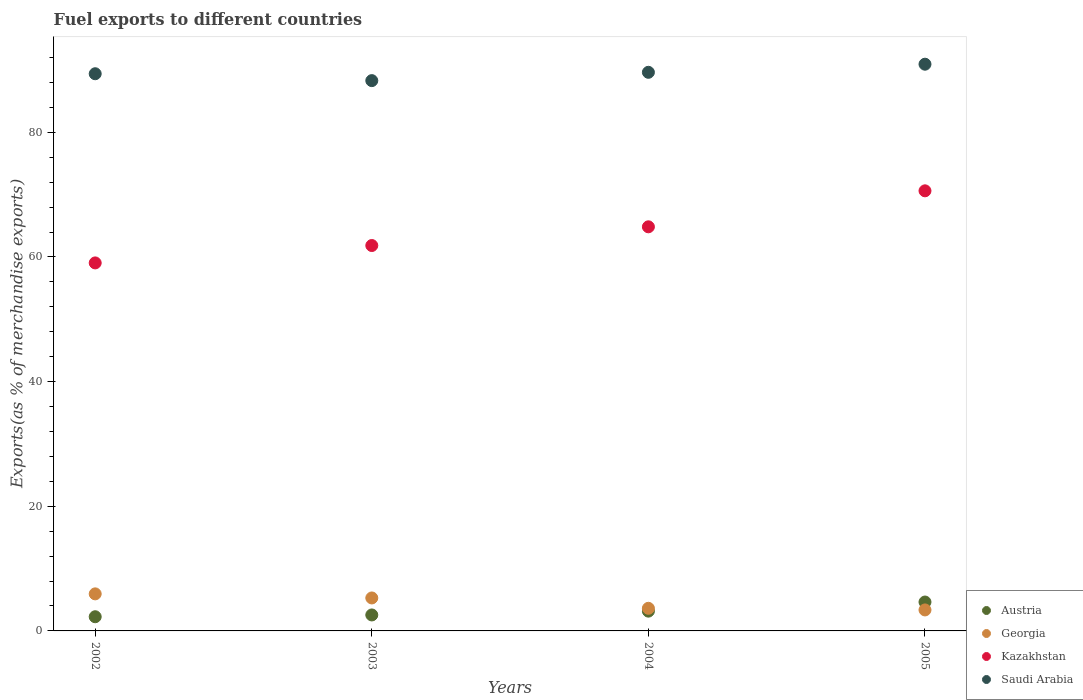What is the percentage of exports to different countries in Georgia in 2004?
Your response must be concise. 3.63. Across all years, what is the maximum percentage of exports to different countries in Georgia?
Give a very brief answer. 5.95. Across all years, what is the minimum percentage of exports to different countries in Saudi Arabia?
Keep it short and to the point. 88.3. In which year was the percentage of exports to different countries in Saudi Arabia maximum?
Your answer should be compact. 2005. What is the total percentage of exports to different countries in Austria in the graph?
Offer a terse response. 12.65. What is the difference between the percentage of exports to different countries in Kazakhstan in 2003 and that in 2005?
Offer a very short reply. -8.78. What is the difference between the percentage of exports to different countries in Saudi Arabia in 2004 and the percentage of exports to different countries in Georgia in 2002?
Ensure brevity in your answer.  83.69. What is the average percentage of exports to different countries in Kazakhstan per year?
Your response must be concise. 64.09. In the year 2002, what is the difference between the percentage of exports to different countries in Georgia and percentage of exports to different countries in Kazakhstan?
Keep it short and to the point. -53.1. What is the ratio of the percentage of exports to different countries in Kazakhstan in 2002 to that in 2003?
Provide a short and direct response. 0.95. Is the difference between the percentage of exports to different countries in Georgia in 2002 and 2003 greater than the difference between the percentage of exports to different countries in Kazakhstan in 2002 and 2003?
Keep it short and to the point. Yes. What is the difference between the highest and the second highest percentage of exports to different countries in Georgia?
Your answer should be compact. 0.66. What is the difference between the highest and the lowest percentage of exports to different countries in Saudi Arabia?
Your answer should be very brief. 2.64. In how many years, is the percentage of exports to different countries in Georgia greater than the average percentage of exports to different countries in Georgia taken over all years?
Give a very brief answer. 2. Is it the case that in every year, the sum of the percentage of exports to different countries in Austria and percentage of exports to different countries in Kazakhstan  is greater than the percentage of exports to different countries in Saudi Arabia?
Keep it short and to the point. No. Is the percentage of exports to different countries in Kazakhstan strictly greater than the percentage of exports to different countries in Georgia over the years?
Offer a very short reply. Yes. Is the percentage of exports to different countries in Georgia strictly less than the percentage of exports to different countries in Austria over the years?
Provide a short and direct response. No. How many dotlines are there?
Make the answer very short. 4. What is the difference between two consecutive major ticks on the Y-axis?
Your answer should be compact. 20. Are the values on the major ticks of Y-axis written in scientific E-notation?
Make the answer very short. No. Does the graph contain any zero values?
Keep it short and to the point. No. Where does the legend appear in the graph?
Your response must be concise. Bottom right. How many legend labels are there?
Make the answer very short. 4. What is the title of the graph?
Make the answer very short. Fuel exports to different countries. What is the label or title of the X-axis?
Your response must be concise. Years. What is the label or title of the Y-axis?
Give a very brief answer. Exports(as % of merchandise exports). What is the Exports(as % of merchandise exports) in Austria in 2002?
Provide a short and direct response. 2.28. What is the Exports(as % of merchandise exports) of Georgia in 2002?
Your response must be concise. 5.95. What is the Exports(as % of merchandise exports) in Kazakhstan in 2002?
Offer a terse response. 59.05. What is the Exports(as % of merchandise exports) of Saudi Arabia in 2002?
Give a very brief answer. 89.4. What is the Exports(as % of merchandise exports) in Austria in 2003?
Give a very brief answer. 2.56. What is the Exports(as % of merchandise exports) in Georgia in 2003?
Offer a terse response. 5.29. What is the Exports(as % of merchandise exports) in Kazakhstan in 2003?
Give a very brief answer. 61.84. What is the Exports(as % of merchandise exports) of Saudi Arabia in 2003?
Provide a short and direct response. 88.3. What is the Exports(as % of merchandise exports) in Austria in 2004?
Make the answer very short. 3.17. What is the Exports(as % of merchandise exports) in Georgia in 2004?
Make the answer very short. 3.63. What is the Exports(as % of merchandise exports) of Kazakhstan in 2004?
Your answer should be very brief. 64.84. What is the Exports(as % of merchandise exports) of Saudi Arabia in 2004?
Your answer should be compact. 89.63. What is the Exports(as % of merchandise exports) of Austria in 2005?
Your answer should be very brief. 4.64. What is the Exports(as % of merchandise exports) of Georgia in 2005?
Your answer should be very brief. 3.37. What is the Exports(as % of merchandise exports) in Kazakhstan in 2005?
Provide a succinct answer. 70.62. What is the Exports(as % of merchandise exports) in Saudi Arabia in 2005?
Keep it short and to the point. 90.94. Across all years, what is the maximum Exports(as % of merchandise exports) of Austria?
Your answer should be compact. 4.64. Across all years, what is the maximum Exports(as % of merchandise exports) in Georgia?
Offer a very short reply. 5.95. Across all years, what is the maximum Exports(as % of merchandise exports) in Kazakhstan?
Give a very brief answer. 70.62. Across all years, what is the maximum Exports(as % of merchandise exports) in Saudi Arabia?
Make the answer very short. 90.94. Across all years, what is the minimum Exports(as % of merchandise exports) of Austria?
Give a very brief answer. 2.28. Across all years, what is the minimum Exports(as % of merchandise exports) in Georgia?
Your answer should be compact. 3.37. Across all years, what is the minimum Exports(as % of merchandise exports) of Kazakhstan?
Offer a very short reply. 59.05. Across all years, what is the minimum Exports(as % of merchandise exports) in Saudi Arabia?
Make the answer very short. 88.3. What is the total Exports(as % of merchandise exports) in Austria in the graph?
Give a very brief answer. 12.65. What is the total Exports(as % of merchandise exports) of Georgia in the graph?
Ensure brevity in your answer.  18.23. What is the total Exports(as % of merchandise exports) of Kazakhstan in the graph?
Your answer should be very brief. 256.35. What is the total Exports(as % of merchandise exports) of Saudi Arabia in the graph?
Your answer should be very brief. 358.28. What is the difference between the Exports(as % of merchandise exports) of Austria in 2002 and that in 2003?
Offer a terse response. -0.29. What is the difference between the Exports(as % of merchandise exports) in Georgia in 2002 and that in 2003?
Keep it short and to the point. 0.66. What is the difference between the Exports(as % of merchandise exports) of Kazakhstan in 2002 and that in 2003?
Ensure brevity in your answer.  -2.79. What is the difference between the Exports(as % of merchandise exports) of Saudi Arabia in 2002 and that in 2003?
Give a very brief answer. 1.1. What is the difference between the Exports(as % of merchandise exports) in Austria in 2002 and that in 2004?
Make the answer very short. -0.9. What is the difference between the Exports(as % of merchandise exports) of Georgia in 2002 and that in 2004?
Your response must be concise. 2.31. What is the difference between the Exports(as % of merchandise exports) of Kazakhstan in 2002 and that in 2004?
Offer a terse response. -5.79. What is the difference between the Exports(as % of merchandise exports) of Saudi Arabia in 2002 and that in 2004?
Make the answer very short. -0.23. What is the difference between the Exports(as % of merchandise exports) of Austria in 2002 and that in 2005?
Give a very brief answer. -2.36. What is the difference between the Exports(as % of merchandise exports) of Georgia in 2002 and that in 2005?
Give a very brief answer. 2.58. What is the difference between the Exports(as % of merchandise exports) of Kazakhstan in 2002 and that in 2005?
Your response must be concise. -11.57. What is the difference between the Exports(as % of merchandise exports) in Saudi Arabia in 2002 and that in 2005?
Offer a terse response. -1.53. What is the difference between the Exports(as % of merchandise exports) in Austria in 2003 and that in 2004?
Your response must be concise. -0.61. What is the difference between the Exports(as % of merchandise exports) of Georgia in 2003 and that in 2004?
Provide a succinct answer. 1.66. What is the difference between the Exports(as % of merchandise exports) of Kazakhstan in 2003 and that in 2004?
Make the answer very short. -3. What is the difference between the Exports(as % of merchandise exports) of Saudi Arabia in 2003 and that in 2004?
Give a very brief answer. -1.33. What is the difference between the Exports(as % of merchandise exports) of Austria in 2003 and that in 2005?
Give a very brief answer. -2.07. What is the difference between the Exports(as % of merchandise exports) of Georgia in 2003 and that in 2005?
Provide a short and direct response. 1.92. What is the difference between the Exports(as % of merchandise exports) of Kazakhstan in 2003 and that in 2005?
Offer a terse response. -8.78. What is the difference between the Exports(as % of merchandise exports) in Saudi Arabia in 2003 and that in 2005?
Your answer should be very brief. -2.64. What is the difference between the Exports(as % of merchandise exports) in Austria in 2004 and that in 2005?
Offer a very short reply. -1.46. What is the difference between the Exports(as % of merchandise exports) in Georgia in 2004 and that in 2005?
Give a very brief answer. 0.26. What is the difference between the Exports(as % of merchandise exports) of Kazakhstan in 2004 and that in 2005?
Ensure brevity in your answer.  -5.77. What is the difference between the Exports(as % of merchandise exports) of Saudi Arabia in 2004 and that in 2005?
Your answer should be very brief. -1.3. What is the difference between the Exports(as % of merchandise exports) in Austria in 2002 and the Exports(as % of merchandise exports) in Georgia in 2003?
Your answer should be compact. -3.01. What is the difference between the Exports(as % of merchandise exports) of Austria in 2002 and the Exports(as % of merchandise exports) of Kazakhstan in 2003?
Offer a terse response. -59.57. What is the difference between the Exports(as % of merchandise exports) in Austria in 2002 and the Exports(as % of merchandise exports) in Saudi Arabia in 2003?
Keep it short and to the point. -86.02. What is the difference between the Exports(as % of merchandise exports) in Georgia in 2002 and the Exports(as % of merchandise exports) in Kazakhstan in 2003?
Keep it short and to the point. -55.9. What is the difference between the Exports(as % of merchandise exports) in Georgia in 2002 and the Exports(as % of merchandise exports) in Saudi Arabia in 2003?
Ensure brevity in your answer.  -82.35. What is the difference between the Exports(as % of merchandise exports) of Kazakhstan in 2002 and the Exports(as % of merchandise exports) of Saudi Arabia in 2003?
Give a very brief answer. -29.25. What is the difference between the Exports(as % of merchandise exports) in Austria in 2002 and the Exports(as % of merchandise exports) in Georgia in 2004?
Make the answer very short. -1.35. What is the difference between the Exports(as % of merchandise exports) of Austria in 2002 and the Exports(as % of merchandise exports) of Kazakhstan in 2004?
Your answer should be very brief. -62.57. What is the difference between the Exports(as % of merchandise exports) of Austria in 2002 and the Exports(as % of merchandise exports) of Saudi Arabia in 2004?
Your answer should be very brief. -87.36. What is the difference between the Exports(as % of merchandise exports) of Georgia in 2002 and the Exports(as % of merchandise exports) of Kazakhstan in 2004?
Give a very brief answer. -58.9. What is the difference between the Exports(as % of merchandise exports) of Georgia in 2002 and the Exports(as % of merchandise exports) of Saudi Arabia in 2004?
Provide a succinct answer. -83.69. What is the difference between the Exports(as % of merchandise exports) in Kazakhstan in 2002 and the Exports(as % of merchandise exports) in Saudi Arabia in 2004?
Make the answer very short. -30.58. What is the difference between the Exports(as % of merchandise exports) in Austria in 2002 and the Exports(as % of merchandise exports) in Georgia in 2005?
Make the answer very short. -1.09. What is the difference between the Exports(as % of merchandise exports) in Austria in 2002 and the Exports(as % of merchandise exports) in Kazakhstan in 2005?
Ensure brevity in your answer.  -68.34. What is the difference between the Exports(as % of merchandise exports) of Austria in 2002 and the Exports(as % of merchandise exports) of Saudi Arabia in 2005?
Your answer should be very brief. -88.66. What is the difference between the Exports(as % of merchandise exports) of Georgia in 2002 and the Exports(as % of merchandise exports) of Kazakhstan in 2005?
Provide a short and direct response. -64.67. What is the difference between the Exports(as % of merchandise exports) of Georgia in 2002 and the Exports(as % of merchandise exports) of Saudi Arabia in 2005?
Ensure brevity in your answer.  -84.99. What is the difference between the Exports(as % of merchandise exports) in Kazakhstan in 2002 and the Exports(as % of merchandise exports) in Saudi Arabia in 2005?
Keep it short and to the point. -31.89. What is the difference between the Exports(as % of merchandise exports) in Austria in 2003 and the Exports(as % of merchandise exports) in Georgia in 2004?
Make the answer very short. -1.07. What is the difference between the Exports(as % of merchandise exports) in Austria in 2003 and the Exports(as % of merchandise exports) in Kazakhstan in 2004?
Make the answer very short. -62.28. What is the difference between the Exports(as % of merchandise exports) in Austria in 2003 and the Exports(as % of merchandise exports) in Saudi Arabia in 2004?
Make the answer very short. -87.07. What is the difference between the Exports(as % of merchandise exports) in Georgia in 2003 and the Exports(as % of merchandise exports) in Kazakhstan in 2004?
Ensure brevity in your answer.  -59.55. What is the difference between the Exports(as % of merchandise exports) of Georgia in 2003 and the Exports(as % of merchandise exports) of Saudi Arabia in 2004?
Your answer should be very brief. -84.34. What is the difference between the Exports(as % of merchandise exports) in Kazakhstan in 2003 and the Exports(as % of merchandise exports) in Saudi Arabia in 2004?
Your response must be concise. -27.79. What is the difference between the Exports(as % of merchandise exports) in Austria in 2003 and the Exports(as % of merchandise exports) in Georgia in 2005?
Your answer should be compact. -0.81. What is the difference between the Exports(as % of merchandise exports) in Austria in 2003 and the Exports(as % of merchandise exports) in Kazakhstan in 2005?
Give a very brief answer. -68.06. What is the difference between the Exports(as % of merchandise exports) in Austria in 2003 and the Exports(as % of merchandise exports) in Saudi Arabia in 2005?
Offer a terse response. -88.37. What is the difference between the Exports(as % of merchandise exports) of Georgia in 2003 and the Exports(as % of merchandise exports) of Kazakhstan in 2005?
Give a very brief answer. -65.33. What is the difference between the Exports(as % of merchandise exports) of Georgia in 2003 and the Exports(as % of merchandise exports) of Saudi Arabia in 2005?
Your answer should be compact. -85.65. What is the difference between the Exports(as % of merchandise exports) in Kazakhstan in 2003 and the Exports(as % of merchandise exports) in Saudi Arabia in 2005?
Your answer should be very brief. -29.09. What is the difference between the Exports(as % of merchandise exports) of Austria in 2004 and the Exports(as % of merchandise exports) of Georgia in 2005?
Your response must be concise. -0.19. What is the difference between the Exports(as % of merchandise exports) of Austria in 2004 and the Exports(as % of merchandise exports) of Kazakhstan in 2005?
Keep it short and to the point. -67.44. What is the difference between the Exports(as % of merchandise exports) in Austria in 2004 and the Exports(as % of merchandise exports) in Saudi Arabia in 2005?
Offer a very short reply. -87.76. What is the difference between the Exports(as % of merchandise exports) in Georgia in 2004 and the Exports(as % of merchandise exports) in Kazakhstan in 2005?
Provide a short and direct response. -66.99. What is the difference between the Exports(as % of merchandise exports) in Georgia in 2004 and the Exports(as % of merchandise exports) in Saudi Arabia in 2005?
Your response must be concise. -87.31. What is the difference between the Exports(as % of merchandise exports) of Kazakhstan in 2004 and the Exports(as % of merchandise exports) of Saudi Arabia in 2005?
Make the answer very short. -26.09. What is the average Exports(as % of merchandise exports) of Austria per year?
Your answer should be compact. 3.16. What is the average Exports(as % of merchandise exports) of Georgia per year?
Provide a succinct answer. 4.56. What is the average Exports(as % of merchandise exports) in Kazakhstan per year?
Offer a very short reply. 64.09. What is the average Exports(as % of merchandise exports) in Saudi Arabia per year?
Your response must be concise. 89.57. In the year 2002, what is the difference between the Exports(as % of merchandise exports) in Austria and Exports(as % of merchandise exports) in Georgia?
Give a very brief answer. -3.67. In the year 2002, what is the difference between the Exports(as % of merchandise exports) of Austria and Exports(as % of merchandise exports) of Kazakhstan?
Your answer should be very brief. -56.77. In the year 2002, what is the difference between the Exports(as % of merchandise exports) of Austria and Exports(as % of merchandise exports) of Saudi Arabia?
Keep it short and to the point. -87.13. In the year 2002, what is the difference between the Exports(as % of merchandise exports) of Georgia and Exports(as % of merchandise exports) of Kazakhstan?
Your response must be concise. -53.1. In the year 2002, what is the difference between the Exports(as % of merchandise exports) of Georgia and Exports(as % of merchandise exports) of Saudi Arabia?
Keep it short and to the point. -83.46. In the year 2002, what is the difference between the Exports(as % of merchandise exports) in Kazakhstan and Exports(as % of merchandise exports) in Saudi Arabia?
Ensure brevity in your answer.  -30.35. In the year 2003, what is the difference between the Exports(as % of merchandise exports) in Austria and Exports(as % of merchandise exports) in Georgia?
Provide a succinct answer. -2.73. In the year 2003, what is the difference between the Exports(as % of merchandise exports) in Austria and Exports(as % of merchandise exports) in Kazakhstan?
Provide a succinct answer. -59.28. In the year 2003, what is the difference between the Exports(as % of merchandise exports) of Austria and Exports(as % of merchandise exports) of Saudi Arabia?
Offer a very short reply. -85.74. In the year 2003, what is the difference between the Exports(as % of merchandise exports) of Georgia and Exports(as % of merchandise exports) of Kazakhstan?
Make the answer very short. -56.55. In the year 2003, what is the difference between the Exports(as % of merchandise exports) of Georgia and Exports(as % of merchandise exports) of Saudi Arabia?
Provide a short and direct response. -83.01. In the year 2003, what is the difference between the Exports(as % of merchandise exports) of Kazakhstan and Exports(as % of merchandise exports) of Saudi Arabia?
Offer a very short reply. -26.46. In the year 2004, what is the difference between the Exports(as % of merchandise exports) in Austria and Exports(as % of merchandise exports) in Georgia?
Offer a very short reply. -0.46. In the year 2004, what is the difference between the Exports(as % of merchandise exports) of Austria and Exports(as % of merchandise exports) of Kazakhstan?
Keep it short and to the point. -61.67. In the year 2004, what is the difference between the Exports(as % of merchandise exports) in Austria and Exports(as % of merchandise exports) in Saudi Arabia?
Provide a succinct answer. -86.46. In the year 2004, what is the difference between the Exports(as % of merchandise exports) in Georgia and Exports(as % of merchandise exports) in Kazakhstan?
Keep it short and to the point. -61.21. In the year 2004, what is the difference between the Exports(as % of merchandise exports) of Georgia and Exports(as % of merchandise exports) of Saudi Arabia?
Your response must be concise. -86. In the year 2004, what is the difference between the Exports(as % of merchandise exports) of Kazakhstan and Exports(as % of merchandise exports) of Saudi Arabia?
Keep it short and to the point. -24.79. In the year 2005, what is the difference between the Exports(as % of merchandise exports) of Austria and Exports(as % of merchandise exports) of Georgia?
Keep it short and to the point. 1.27. In the year 2005, what is the difference between the Exports(as % of merchandise exports) in Austria and Exports(as % of merchandise exports) in Kazakhstan?
Give a very brief answer. -65.98. In the year 2005, what is the difference between the Exports(as % of merchandise exports) in Austria and Exports(as % of merchandise exports) in Saudi Arabia?
Provide a short and direct response. -86.3. In the year 2005, what is the difference between the Exports(as % of merchandise exports) in Georgia and Exports(as % of merchandise exports) in Kazakhstan?
Your response must be concise. -67.25. In the year 2005, what is the difference between the Exports(as % of merchandise exports) of Georgia and Exports(as % of merchandise exports) of Saudi Arabia?
Offer a terse response. -87.57. In the year 2005, what is the difference between the Exports(as % of merchandise exports) of Kazakhstan and Exports(as % of merchandise exports) of Saudi Arabia?
Your answer should be very brief. -20.32. What is the ratio of the Exports(as % of merchandise exports) in Austria in 2002 to that in 2003?
Offer a very short reply. 0.89. What is the ratio of the Exports(as % of merchandise exports) in Georgia in 2002 to that in 2003?
Offer a terse response. 1.12. What is the ratio of the Exports(as % of merchandise exports) in Kazakhstan in 2002 to that in 2003?
Keep it short and to the point. 0.95. What is the ratio of the Exports(as % of merchandise exports) in Saudi Arabia in 2002 to that in 2003?
Your response must be concise. 1.01. What is the ratio of the Exports(as % of merchandise exports) of Austria in 2002 to that in 2004?
Provide a succinct answer. 0.72. What is the ratio of the Exports(as % of merchandise exports) in Georgia in 2002 to that in 2004?
Offer a very short reply. 1.64. What is the ratio of the Exports(as % of merchandise exports) of Kazakhstan in 2002 to that in 2004?
Offer a terse response. 0.91. What is the ratio of the Exports(as % of merchandise exports) of Saudi Arabia in 2002 to that in 2004?
Give a very brief answer. 1. What is the ratio of the Exports(as % of merchandise exports) of Austria in 2002 to that in 2005?
Offer a terse response. 0.49. What is the ratio of the Exports(as % of merchandise exports) in Georgia in 2002 to that in 2005?
Your answer should be compact. 1.77. What is the ratio of the Exports(as % of merchandise exports) in Kazakhstan in 2002 to that in 2005?
Your answer should be very brief. 0.84. What is the ratio of the Exports(as % of merchandise exports) of Saudi Arabia in 2002 to that in 2005?
Ensure brevity in your answer.  0.98. What is the ratio of the Exports(as % of merchandise exports) in Austria in 2003 to that in 2004?
Give a very brief answer. 0.81. What is the ratio of the Exports(as % of merchandise exports) of Georgia in 2003 to that in 2004?
Offer a very short reply. 1.46. What is the ratio of the Exports(as % of merchandise exports) of Kazakhstan in 2003 to that in 2004?
Provide a short and direct response. 0.95. What is the ratio of the Exports(as % of merchandise exports) of Saudi Arabia in 2003 to that in 2004?
Ensure brevity in your answer.  0.99. What is the ratio of the Exports(as % of merchandise exports) in Austria in 2003 to that in 2005?
Provide a succinct answer. 0.55. What is the ratio of the Exports(as % of merchandise exports) of Georgia in 2003 to that in 2005?
Ensure brevity in your answer.  1.57. What is the ratio of the Exports(as % of merchandise exports) in Kazakhstan in 2003 to that in 2005?
Provide a short and direct response. 0.88. What is the ratio of the Exports(as % of merchandise exports) in Saudi Arabia in 2003 to that in 2005?
Make the answer very short. 0.97. What is the ratio of the Exports(as % of merchandise exports) in Austria in 2004 to that in 2005?
Your response must be concise. 0.68. What is the ratio of the Exports(as % of merchandise exports) in Georgia in 2004 to that in 2005?
Give a very brief answer. 1.08. What is the ratio of the Exports(as % of merchandise exports) in Kazakhstan in 2004 to that in 2005?
Your response must be concise. 0.92. What is the ratio of the Exports(as % of merchandise exports) of Saudi Arabia in 2004 to that in 2005?
Make the answer very short. 0.99. What is the difference between the highest and the second highest Exports(as % of merchandise exports) of Austria?
Your answer should be compact. 1.46. What is the difference between the highest and the second highest Exports(as % of merchandise exports) in Georgia?
Provide a succinct answer. 0.66. What is the difference between the highest and the second highest Exports(as % of merchandise exports) in Kazakhstan?
Make the answer very short. 5.77. What is the difference between the highest and the second highest Exports(as % of merchandise exports) of Saudi Arabia?
Your response must be concise. 1.3. What is the difference between the highest and the lowest Exports(as % of merchandise exports) of Austria?
Give a very brief answer. 2.36. What is the difference between the highest and the lowest Exports(as % of merchandise exports) in Georgia?
Your response must be concise. 2.58. What is the difference between the highest and the lowest Exports(as % of merchandise exports) of Kazakhstan?
Your answer should be very brief. 11.57. What is the difference between the highest and the lowest Exports(as % of merchandise exports) of Saudi Arabia?
Provide a short and direct response. 2.64. 